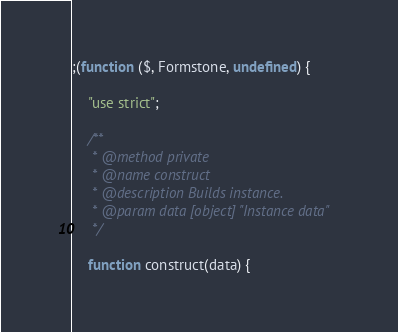Convert code to text. <code><loc_0><loc_0><loc_500><loc_500><_JavaScript_>;(function ($, Formstone, undefined) {

	"use strict";

	/**
	 * @method private
	 * @name construct
	 * @description Builds instance.
	 * @param data [object] "Instance data"
	 */

	function construct(data) {</code> 